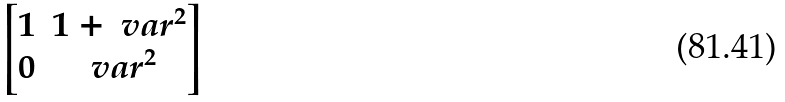Convert formula to latex. <formula><loc_0><loc_0><loc_500><loc_500>\begin{bmatrix} 1 & 1 + \ v a r ^ { 2 } \\ 0 & \ v a r ^ { 2 } \end{bmatrix}</formula> 